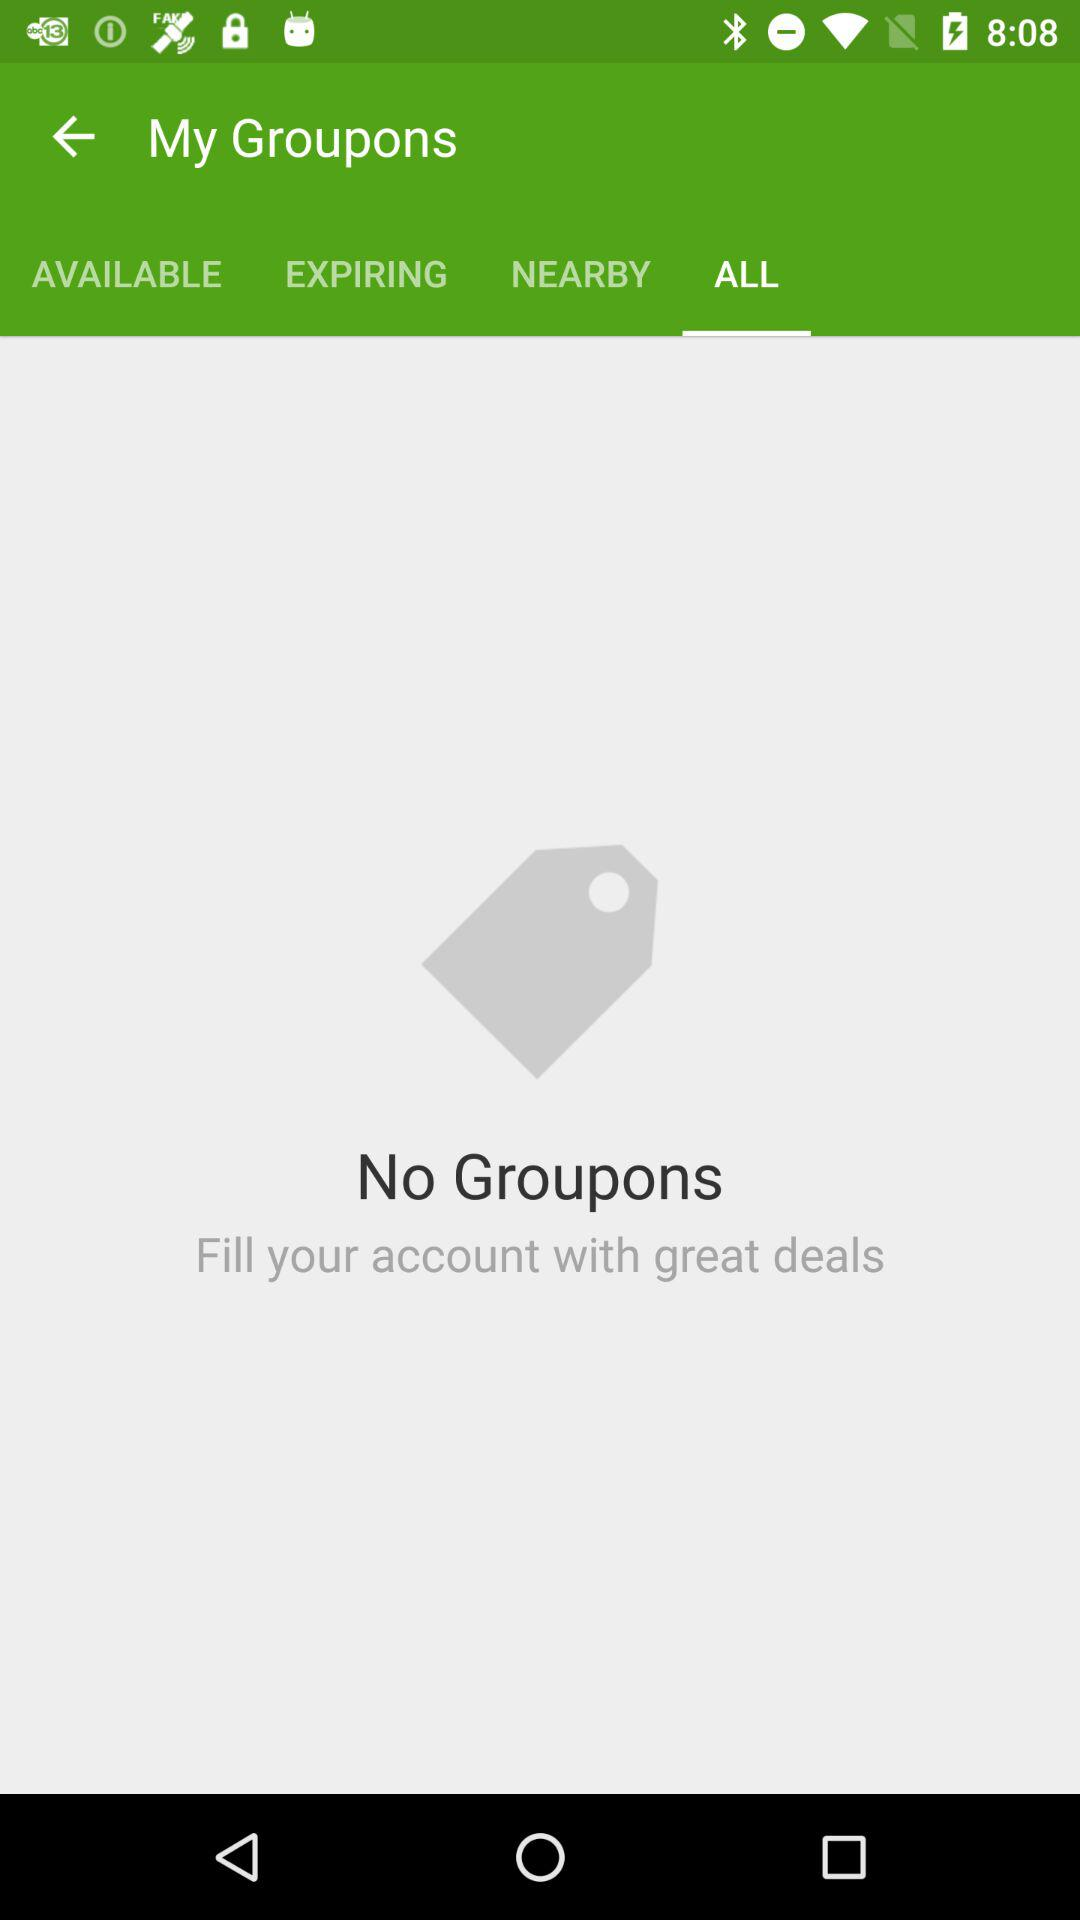Which tab is selected? The selected tab is "ALL". 